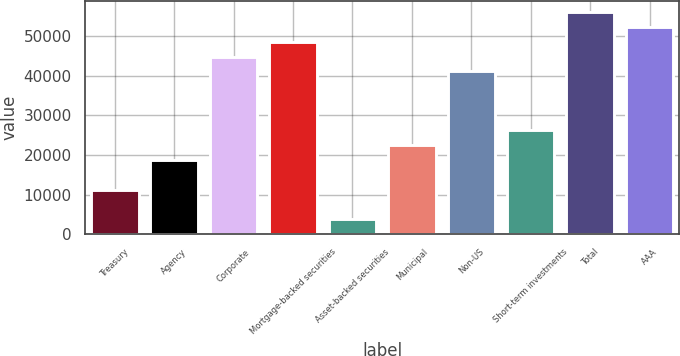Convert chart to OTSL. <chart><loc_0><loc_0><loc_500><loc_500><bar_chart><fcel>Treasury<fcel>Agency<fcel>Corporate<fcel>Mortgage-backed securities<fcel>Asset-backed securities<fcel>Municipal<fcel>Non-US<fcel>Short-term investments<fcel>Total<fcel>AAA<nl><fcel>11279.6<fcel>18734<fcel>44824.4<fcel>48551.6<fcel>3825.2<fcel>22461.2<fcel>41097.2<fcel>26188.4<fcel>56006<fcel>52278.8<nl></chart> 